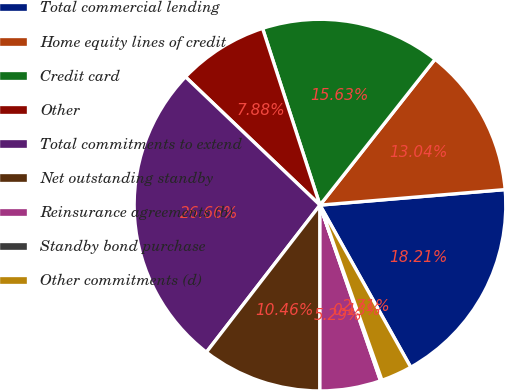<chart> <loc_0><loc_0><loc_500><loc_500><pie_chart><fcel>Total commercial lending<fcel>Home equity lines of credit<fcel>Credit card<fcel>Other<fcel>Total commitments to extend<fcel>Net outstanding standby<fcel>Reinsurance agreements (b)<fcel>Standby bond purchase<fcel>Other commitments (d)<nl><fcel>18.21%<fcel>13.04%<fcel>15.63%<fcel>7.88%<fcel>26.66%<fcel>10.46%<fcel>5.29%<fcel>0.13%<fcel>2.71%<nl></chart> 